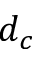<formula> <loc_0><loc_0><loc_500><loc_500>d _ { c }</formula> 